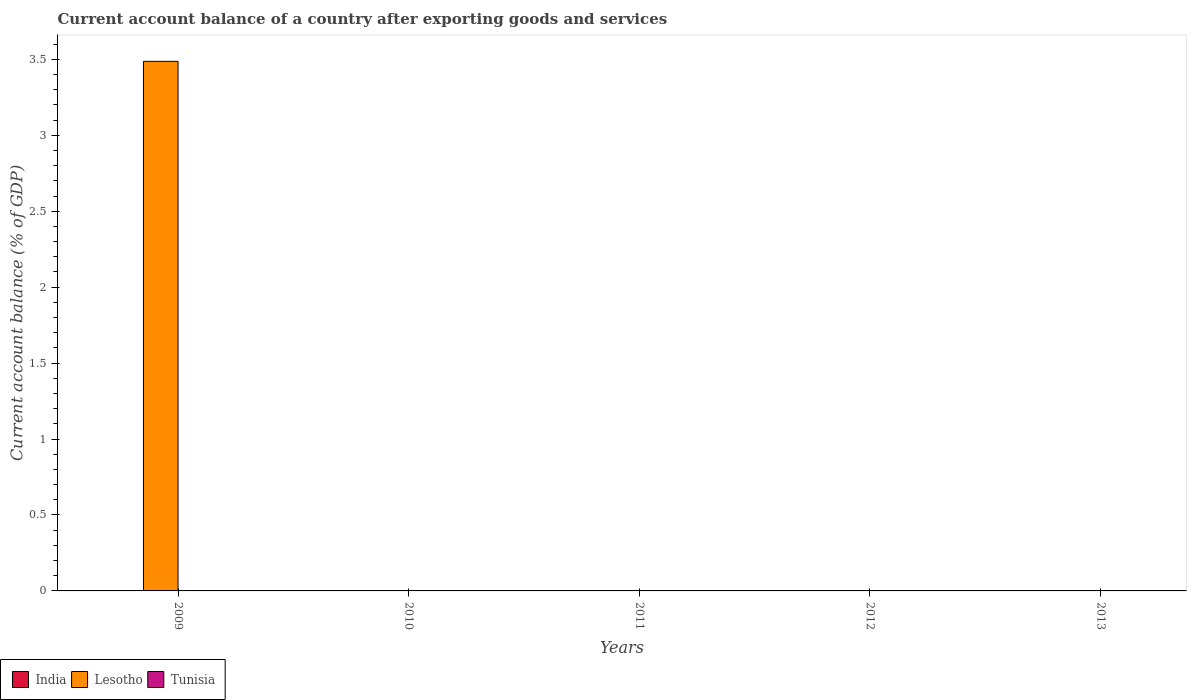Are the number of bars per tick equal to the number of legend labels?
Offer a terse response. No. Are the number of bars on each tick of the X-axis equal?
Ensure brevity in your answer.  No. How many bars are there on the 3rd tick from the right?
Provide a short and direct response. 0. What is the label of the 2nd group of bars from the left?
Offer a very short reply. 2010. In how many cases, is the number of bars for a given year not equal to the number of legend labels?
Offer a terse response. 5. Across all years, what is the maximum account balance in Lesotho?
Give a very brief answer. 3.49. What is the difference between the highest and the lowest account balance in Lesotho?
Offer a terse response. 3.49. What is the difference between two consecutive major ticks on the Y-axis?
Provide a succinct answer. 0.5. Are the values on the major ticks of Y-axis written in scientific E-notation?
Provide a succinct answer. No. Where does the legend appear in the graph?
Keep it short and to the point. Bottom left. How are the legend labels stacked?
Offer a terse response. Horizontal. What is the title of the graph?
Your response must be concise. Current account balance of a country after exporting goods and services. What is the label or title of the X-axis?
Provide a short and direct response. Years. What is the label or title of the Y-axis?
Your answer should be very brief. Current account balance (% of GDP). What is the Current account balance (% of GDP) in Lesotho in 2009?
Ensure brevity in your answer.  3.49. What is the Current account balance (% of GDP) in Tunisia in 2010?
Offer a very short reply. 0. What is the Current account balance (% of GDP) of Lesotho in 2011?
Ensure brevity in your answer.  0. What is the Current account balance (% of GDP) in Lesotho in 2012?
Offer a terse response. 0. What is the Current account balance (% of GDP) of Tunisia in 2012?
Make the answer very short. 0. What is the Current account balance (% of GDP) in Lesotho in 2013?
Your answer should be compact. 0. Across all years, what is the maximum Current account balance (% of GDP) of Lesotho?
Make the answer very short. 3.49. What is the total Current account balance (% of GDP) in Lesotho in the graph?
Provide a short and direct response. 3.49. What is the total Current account balance (% of GDP) of Tunisia in the graph?
Offer a very short reply. 0. What is the average Current account balance (% of GDP) in Lesotho per year?
Offer a terse response. 0.7. What is the difference between the highest and the lowest Current account balance (% of GDP) in Lesotho?
Ensure brevity in your answer.  3.49. 